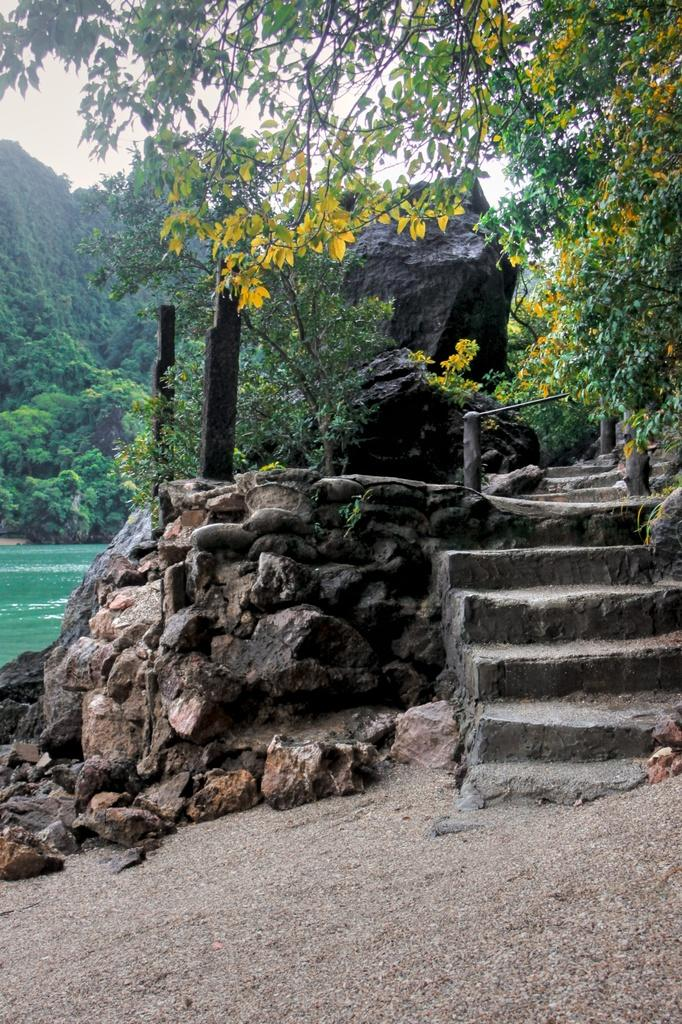What can be seen in the background of the image? There is sky and trees visible in the background of the image. What type of terrain is present in the image? There are rocks, stairs, and wooden poles in the image. What natural element is visible in the image? There is water visible in the image. What type of ground is at the bottom portion of the image? There is sand at the bottom portion of the image. How many matches are in the image? There are no matches present in the image. Where is the faucet located in the image? There is no faucet present in the image. 